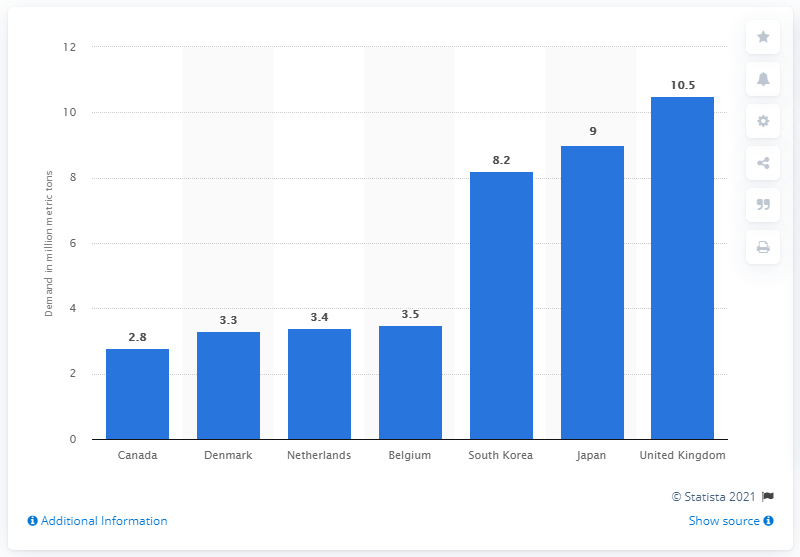Identify some key points in this picture. According to projections, Belgium's demand for industrial wood pellets is expected to reach 3.5 million metric tons in 2025. 